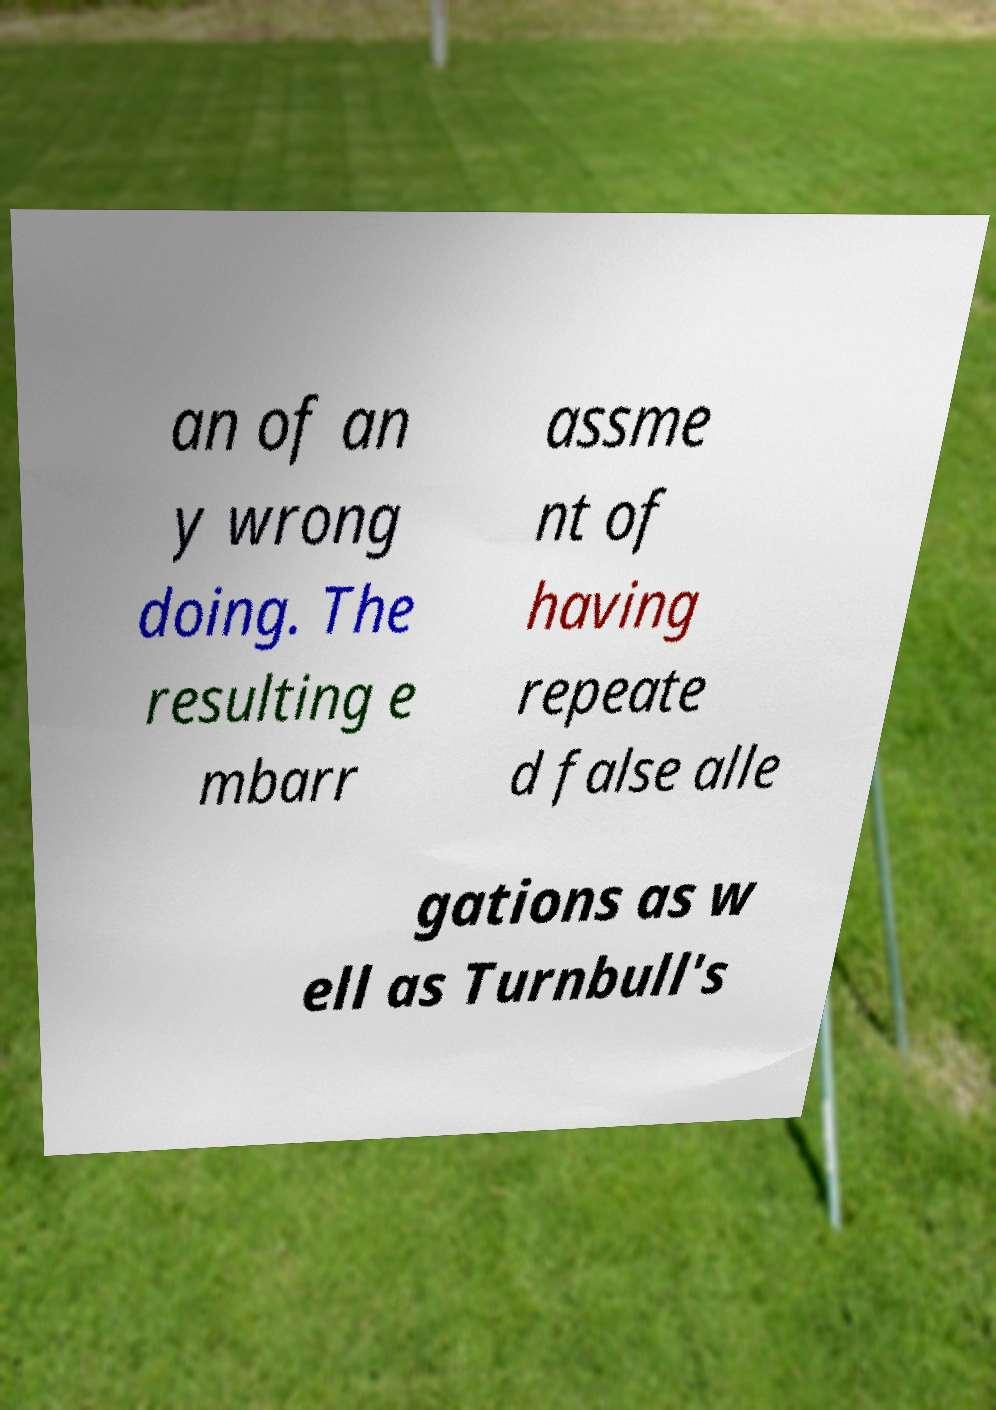For documentation purposes, I need the text within this image transcribed. Could you provide that? an of an y wrong doing. The resulting e mbarr assme nt of having repeate d false alle gations as w ell as Turnbull's 